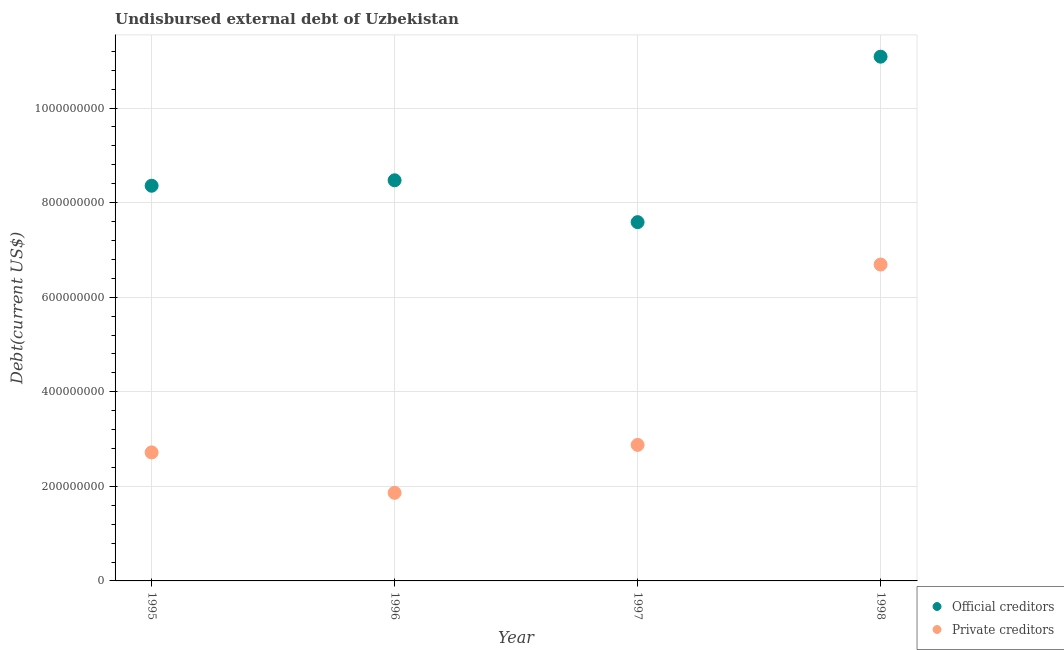How many different coloured dotlines are there?
Keep it short and to the point. 2. What is the undisbursed external debt of official creditors in 1997?
Make the answer very short. 7.59e+08. Across all years, what is the maximum undisbursed external debt of private creditors?
Offer a terse response. 6.69e+08. Across all years, what is the minimum undisbursed external debt of official creditors?
Ensure brevity in your answer.  7.59e+08. What is the total undisbursed external debt of private creditors in the graph?
Offer a very short reply. 1.41e+09. What is the difference between the undisbursed external debt of private creditors in 1997 and that in 1998?
Provide a short and direct response. -3.81e+08. What is the difference between the undisbursed external debt of official creditors in 1998 and the undisbursed external debt of private creditors in 1995?
Give a very brief answer. 8.37e+08. What is the average undisbursed external debt of official creditors per year?
Your answer should be compact. 8.88e+08. In the year 1995, what is the difference between the undisbursed external debt of private creditors and undisbursed external debt of official creditors?
Provide a succinct answer. -5.64e+08. What is the ratio of the undisbursed external debt of private creditors in 1997 to that in 1998?
Your answer should be compact. 0.43. Is the undisbursed external debt of official creditors in 1996 less than that in 1998?
Ensure brevity in your answer.  Yes. Is the difference between the undisbursed external debt of private creditors in 1995 and 1998 greater than the difference between the undisbursed external debt of official creditors in 1995 and 1998?
Give a very brief answer. No. What is the difference between the highest and the second highest undisbursed external debt of private creditors?
Provide a succinct answer. 3.81e+08. What is the difference between the highest and the lowest undisbursed external debt of official creditors?
Your response must be concise. 3.50e+08. In how many years, is the undisbursed external debt of private creditors greater than the average undisbursed external debt of private creditors taken over all years?
Your response must be concise. 1. Is the sum of the undisbursed external debt of private creditors in 1995 and 1996 greater than the maximum undisbursed external debt of official creditors across all years?
Your answer should be very brief. No. Is the undisbursed external debt of official creditors strictly greater than the undisbursed external debt of private creditors over the years?
Make the answer very short. Yes. How many dotlines are there?
Your response must be concise. 2. Does the graph contain grids?
Your response must be concise. Yes. How many legend labels are there?
Your answer should be very brief. 2. How are the legend labels stacked?
Make the answer very short. Vertical. What is the title of the graph?
Ensure brevity in your answer.  Undisbursed external debt of Uzbekistan. What is the label or title of the Y-axis?
Provide a succinct answer. Debt(current US$). What is the Debt(current US$) of Official creditors in 1995?
Make the answer very short. 8.36e+08. What is the Debt(current US$) in Private creditors in 1995?
Offer a terse response. 2.72e+08. What is the Debt(current US$) in Official creditors in 1996?
Keep it short and to the point. 8.47e+08. What is the Debt(current US$) in Private creditors in 1996?
Keep it short and to the point. 1.86e+08. What is the Debt(current US$) of Official creditors in 1997?
Offer a terse response. 7.59e+08. What is the Debt(current US$) of Private creditors in 1997?
Your answer should be compact. 2.88e+08. What is the Debt(current US$) of Official creditors in 1998?
Your answer should be very brief. 1.11e+09. What is the Debt(current US$) in Private creditors in 1998?
Make the answer very short. 6.69e+08. Across all years, what is the maximum Debt(current US$) of Official creditors?
Offer a very short reply. 1.11e+09. Across all years, what is the maximum Debt(current US$) in Private creditors?
Your response must be concise. 6.69e+08. Across all years, what is the minimum Debt(current US$) in Official creditors?
Ensure brevity in your answer.  7.59e+08. Across all years, what is the minimum Debt(current US$) of Private creditors?
Offer a very short reply. 1.86e+08. What is the total Debt(current US$) in Official creditors in the graph?
Keep it short and to the point. 3.55e+09. What is the total Debt(current US$) of Private creditors in the graph?
Give a very brief answer. 1.41e+09. What is the difference between the Debt(current US$) of Official creditors in 1995 and that in 1996?
Give a very brief answer. -1.15e+07. What is the difference between the Debt(current US$) in Private creditors in 1995 and that in 1996?
Offer a very short reply. 8.55e+07. What is the difference between the Debt(current US$) of Official creditors in 1995 and that in 1997?
Offer a terse response. 7.70e+07. What is the difference between the Debt(current US$) in Private creditors in 1995 and that in 1997?
Your answer should be very brief. -1.59e+07. What is the difference between the Debt(current US$) in Official creditors in 1995 and that in 1998?
Keep it short and to the point. -2.73e+08. What is the difference between the Debt(current US$) of Private creditors in 1995 and that in 1998?
Provide a succinct answer. -3.97e+08. What is the difference between the Debt(current US$) of Official creditors in 1996 and that in 1997?
Ensure brevity in your answer.  8.85e+07. What is the difference between the Debt(current US$) in Private creditors in 1996 and that in 1997?
Offer a very short reply. -1.01e+08. What is the difference between the Debt(current US$) in Official creditors in 1996 and that in 1998?
Offer a terse response. -2.61e+08. What is the difference between the Debt(current US$) of Private creditors in 1996 and that in 1998?
Ensure brevity in your answer.  -4.83e+08. What is the difference between the Debt(current US$) in Official creditors in 1997 and that in 1998?
Keep it short and to the point. -3.50e+08. What is the difference between the Debt(current US$) of Private creditors in 1997 and that in 1998?
Provide a succinct answer. -3.81e+08. What is the difference between the Debt(current US$) in Official creditors in 1995 and the Debt(current US$) in Private creditors in 1996?
Keep it short and to the point. 6.49e+08. What is the difference between the Debt(current US$) in Official creditors in 1995 and the Debt(current US$) in Private creditors in 1997?
Provide a succinct answer. 5.48e+08. What is the difference between the Debt(current US$) of Official creditors in 1995 and the Debt(current US$) of Private creditors in 1998?
Offer a very short reply. 1.67e+08. What is the difference between the Debt(current US$) in Official creditors in 1996 and the Debt(current US$) in Private creditors in 1997?
Keep it short and to the point. 5.60e+08. What is the difference between the Debt(current US$) in Official creditors in 1996 and the Debt(current US$) in Private creditors in 1998?
Your answer should be very brief. 1.78e+08. What is the difference between the Debt(current US$) of Official creditors in 1997 and the Debt(current US$) of Private creditors in 1998?
Keep it short and to the point. 8.96e+07. What is the average Debt(current US$) of Official creditors per year?
Provide a short and direct response. 8.88e+08. What is the average Debt(current US$) in Private creditors per year?
Give a very brief answer. 3.54e+08. In the year 1995, what is the difference between the Debt(current US$) of Official creditors and Debt(current US$) of Private creditors?
Provide a short and direct response. 5.64e+08. In the year 1996, what is the difference between the Debt(current US$) of Official creditors and Debt(current US$) of Private creditors?
Provide a succinct answer. 6.61e+08. In the year 1997, what is the difference between the Debt(current US$) in Official creditors and Debt(current US$) in Private creditors?
Ensure brevity in your answer.  4.71e+08. In the year 1998, what is the difference between the Debt(current US$) in Official creditors and Debt(current US$) in Private creditors?
Provide a succinct answer. 4.40e+08. What is the ratio of the Debt(current US$) of Official creditors in 1995 to that in 1996?
Your response must be concise. 0.99. What is the ratio of the Debt(current US$) of Private creditors in 1995 to that in 1996?
Provide a succinct answer. 1.46. What is the ratio of the Debt(current US$) of Official creditors in 1995 to that in 1997?
Provide a short and direct response. 1.1. What is the ratio of the Debt(current US$) of Private creditors in 1995 to that in 1997?
Your answer should be very brief. 0.94. What is the ratio of the Debt(current US$) in Official creditors in 1995 to that in 1998?
Ensure brevity in your answer.  0.75. What is the ratio of the Debt(current US$) in Private creditors in 1995 to that in 1998?
Make the answer very short. 0.41. What is the ratio of the Debt(current US$) in Official creditors in 1996 to that in 1997?
Your answer should be very brief. 1.12. What is the ratio of the Debt(current US$) of Private creditors in 1996 to that in 1997?
Your answer should be very brief. 0.65. What is the ratio of the Debt(current US$) in Official creditors in 1996 to that in 1998?
Give a very brief answer. 0.76. What is the ratio of the Debt(current US$) of Private creditors in 1996 to that in 1998?
Ensure brevity in your answer.  0.28. What is the ratio of the Debt(current US$) in Official creditors in 1997 to that in 1998?
Your answer should be very brief. 0.68. What is the ratio of the Debt(current US$) in Private creditors in 1997 to that in 1998?
Offer a terse response. 0.43. What is the difference between the highest and the second highest Debt(current US$) of Official creditors?
Make the answer very short. 2.61e+08. What is the difference between the highest and the second highest Debt(current US$) in Private creditors?
Offer a terse response. 3.81e+08. What is the difference between the highest and the lowest Debt(current US$) in Official creditors?
Give a very brief answer. 3.50e+08. What is the difference between the highest and the lowest Debt(current US$) of Private creditors?
Give a very brief answer. 4.83e+08. 